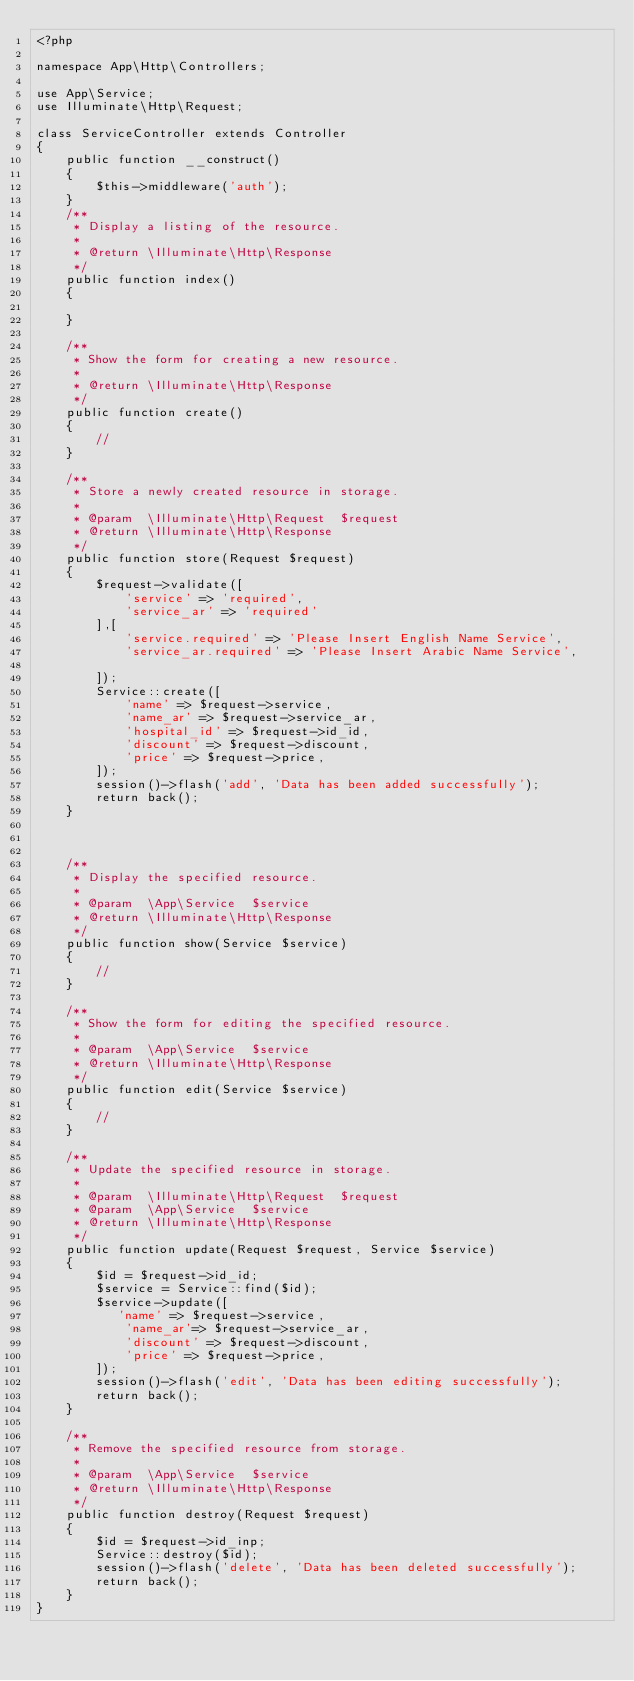Convert code to text. <code><loc_0><loc_0><loc_500><loc_500><_PHP_><?php

namespace App\Http\Controllers;

use App\Service;
use Illuminate\Http\Request;

class ServiceController extends Controller
{
    public function __construct()
    {
        $this->middleware('auth');
    }
    /**
     * Display a listing of the resource.
     *
     * @return \Illuminate\Http\Response
     */
    public function index()
    {

    }

    /**
     * Show the form for creating a new resource.
     *
     * @return \Illuminate\Http\Response
     */
    public function create()
    {
        //
    }

    /**
     * Store a newly created resource in storage.
     *
     * @param  \Illuminate\Http\Request  $request
     * @return \Illuminate\Http\Response
     */
    public function store(Request $request)
    {
        $request->validate([
            'service' => 'required',
            'service_ar' => 'required'
        ],[
            'service.required' => 'Please Insert English Name Service',
            'service_ar.required' => 'Please Insert Arabic Name Service',

        ]);
        Service::create([
            'name' => $request->service,
            'name_ar' => $request->service_ar,
            'hospital_id' => $request->id_id,
            'discount' => $request->discount,
            'price' => $request->price,
        ]);
        session()->flash('add', 'Data has been added successfully');
        return back();
    }



    /**
     * Display the specified resource.
     *
     * @param  \App\Service  $service
     * @return \Illuminate\Http\Response
     */
    public function show(Service $service)
    {
        //
    }

    /**
     * Show the form for editing the specified resource.
     *
     * @param  \App\Service  $service
     * @return \Illuminate\Http\Response
     */
    public function edit(Service $service)
    {
        //
    }

    /**
     * Update the specified resource in storage.
     *
     * @param  \Illuminate\Http\Request  $request
     * @param  \App\Service  $service
     * @return \Illuminate\Http\Response
     */
    public function update(Request $request, Service $service)
    {
        $id = $request->id_id;
        $service = Service::find($id);
        $service->update([
           'name' => $request->service,
            'name_ar'=> $request->service_ar,
            'discount' => $request->discount,
            'price' => $request->price,
        ]);
        session()->flash('edit', 'Data has been editing successfully');
        return back();
    }

    /**
     * Remove the specified resource from storage.
     *
     * @param  \App\Service  $service
     * @return \Illuminate\Http\Response
     */
    public function destroy(Request $request)
    {
        $id = $request->id_inp;
        Service::destroy($id);
        session()->flash('delete', 'Data has been deleted successfully');
        return back();
    }
}
</code> 